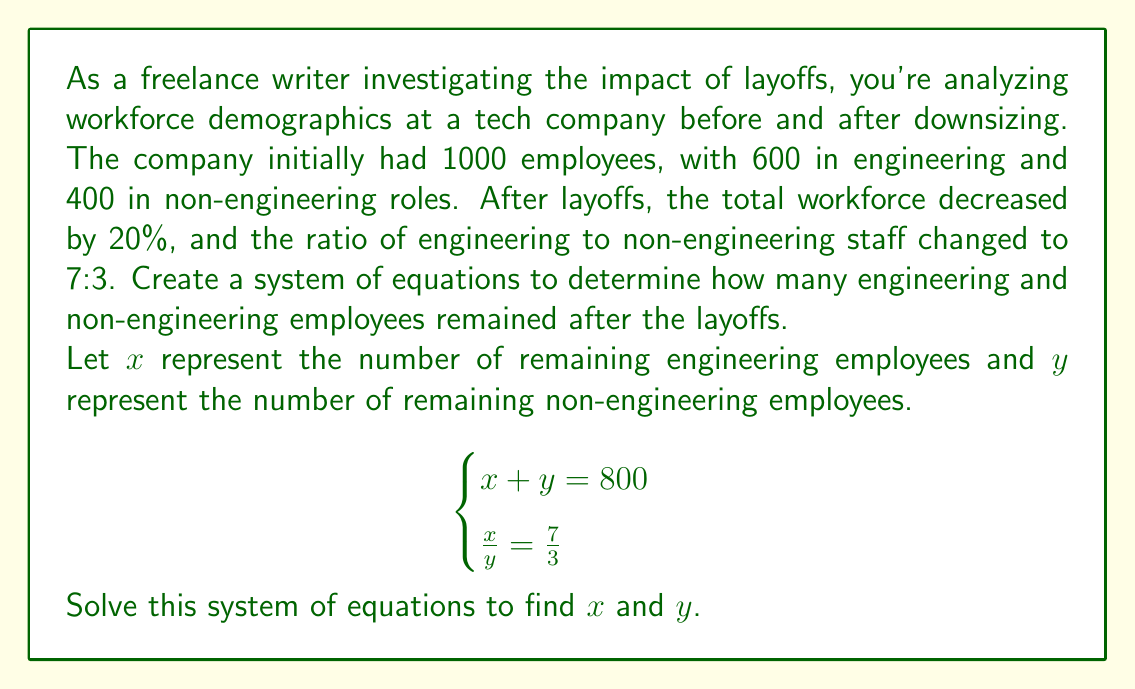Show me your answer to this math problem. To solve this system of equations, we'll use the substitution method:

1) From the first equation: $x + y = 800$

2) From the second equation: $\frac{x}{y} = \frac{7}{3}$
   We can rewrite this as: $x = \frac{7y}{3}$

3) Substitute $x = \frac{7y}{3}$ into the first equation:
   $$\frac{7y}{3} + y = 800$$

4) Simplify:
   $$\frac{7y + 3y}{3} = 800$$
   $$\frac{10y}{3} = 800$$

5) Multiply both sides by 3:
   $$10y = 2400$$

6) Solve for $y$:
   $$y = 240$$

7) Now substitute $y = 240$ back into $x + y = 800$:
   $$x + 240 = 800$$
   $$x = 560$$

8) Verify the ratio:
   $$\frac{x}{y} = \frac{560}{240} = \frac{7}{3}$$

Therefore, after the layoffs, there are 560 engineering employees and 240 non-engineering employees.
Answer: After the layoffs, the company has 560 engineering employees and 240 non-engineering employees. 